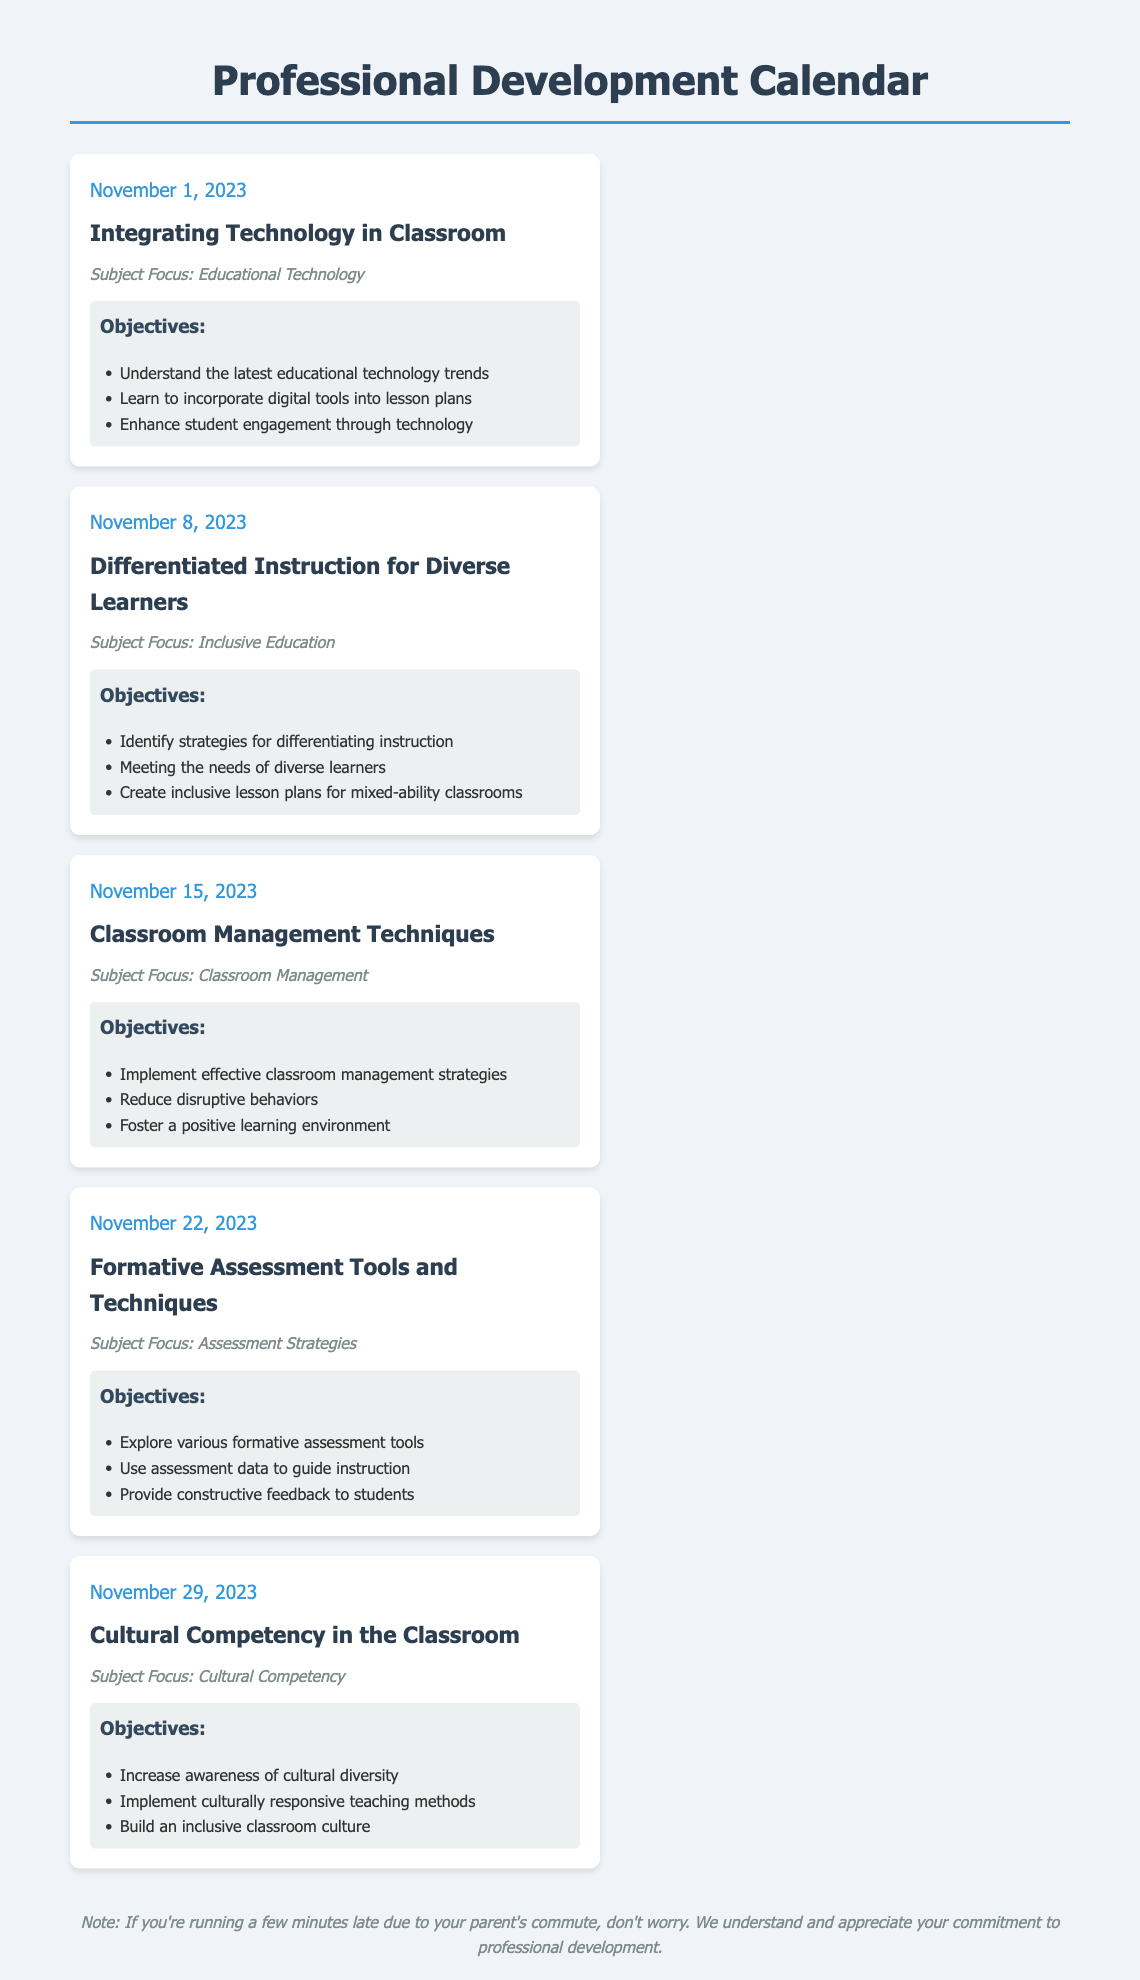What is the first workshop date? The first workshop is on November 1, 2023, which can be found in the date section of the first workshop listed.
Answer: November 1, 2023 What is the title of the workshop on November 8, 2023? The title can be retrieved from the corresponding workshop details for that date.
Answer: Differentiated Instruction for Diverse Learners How many workshops are scheduled in November 2023? There are five workshops listed in the calendar for November 2023.
Answer: 5 What is the focus subject of the workshop on November 15, 2023? The subject focus is specified in the workshop details for that specific date.
Answer: Classroom Management What is one objective of the workshop on November 22, 2023? The objectives for each workshop are listed in bullet points; this requires extracting any point for that workshop date.
Answer: Explore various formative assessment tools Which workshop has a focus on Cultural Competency? The document specifies the subject focus for each workshop; for this question, trace back to the workshop that focuses on this topic.
Answer: Cultural Competency in the Classroom What is the key theme of the last workshop in the calendar? The key theme can be identified by looking at the title of the final workshop on the list.
Answer: Cultural Competency What are the objectives of the workshop titled "Integrating Technology in Classroom"? The objectives are listed directly below the title of that specific workshop, these can be summarized or quoted.
Answer: Understand the latest educational technology trends, Learn to incorporate digital tools into lesson plans, Enhance student engagement through technology 